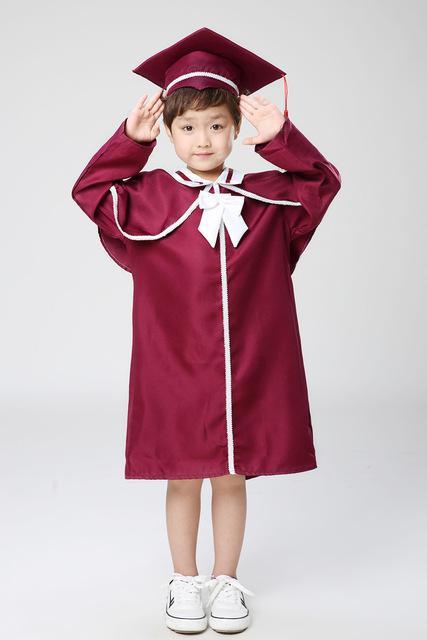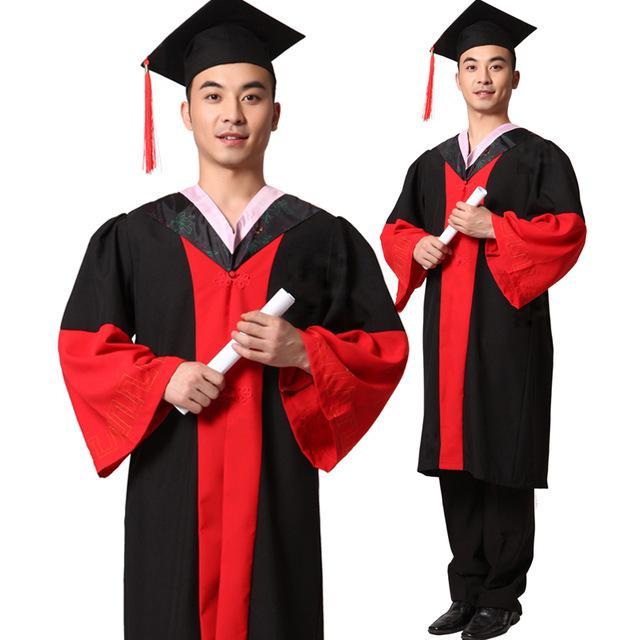The first image is the image on the left, the second image is the image on the right. Analyze the images presented: Is the assertion "a single little girl in a red cap and gown" valid? Answer yes or no. Yes. The first image is the image on the left, the second image is the image on the right. Analyze the images presented: Is the assertion "The people holding diplomas are not wearing glasses." valid? Answer yes or no. Yes. 